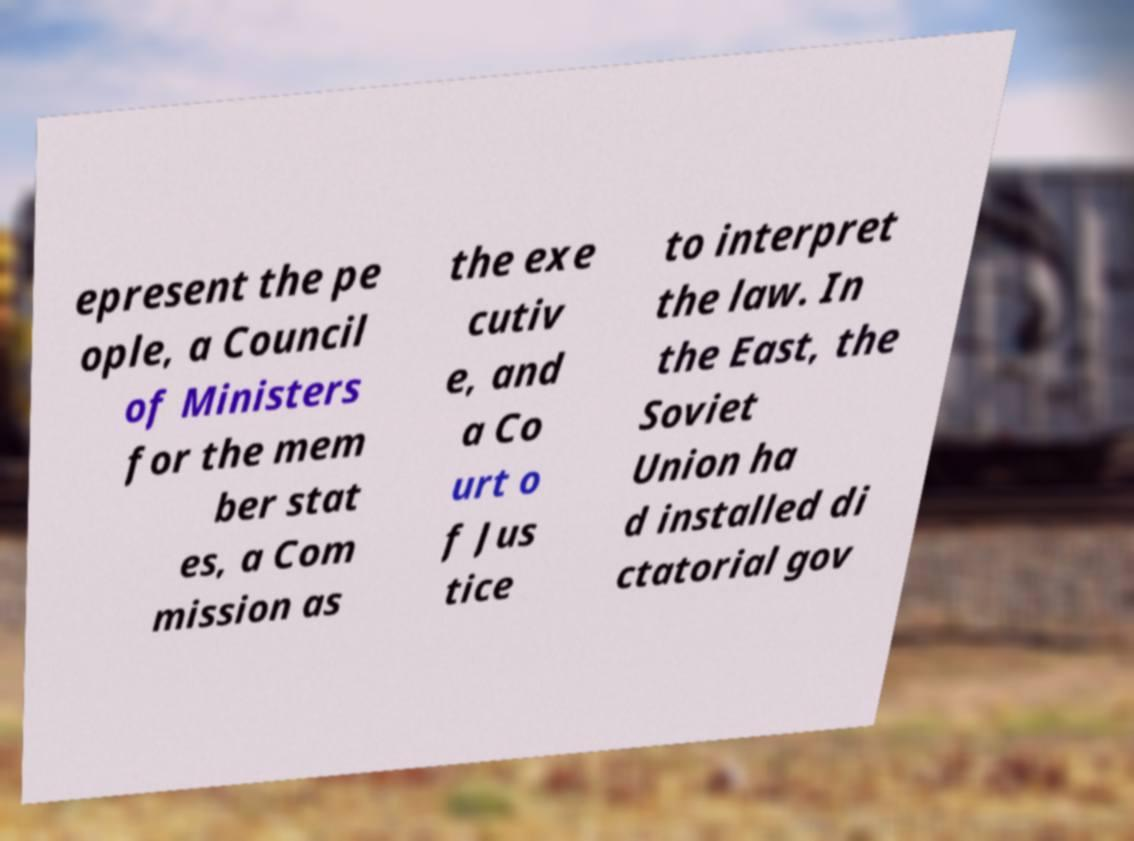For documentation purposes, I need the text within this image transcribed. Could you provide that? epresent the pe ople, a Council of Ministers for the mem ber stat es, a Com mission as the exe cutiv e, and a Co urt o f Jus tice to interpret the law. In the East, the Soviet Union ha d installed di ctatorial gov 